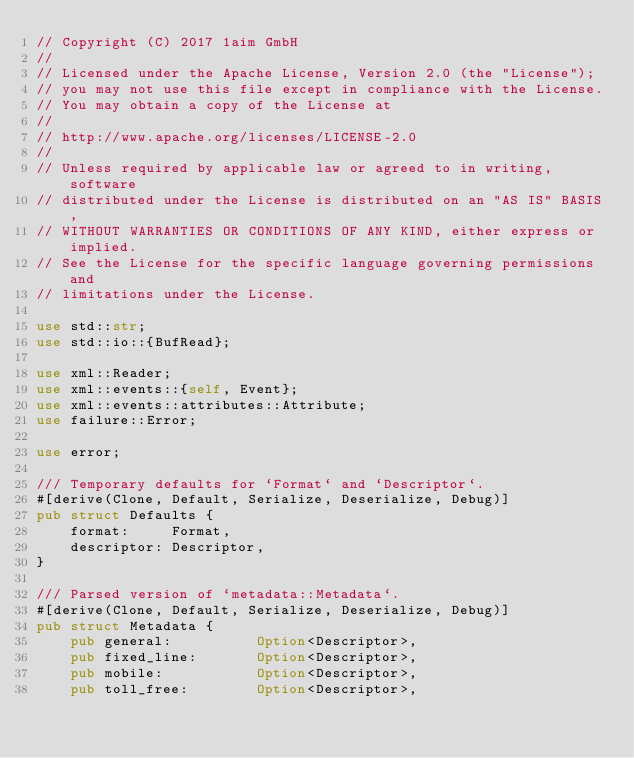Convert code to text. <code><loc_0><loc_0><loc_500><loc_500><_Rust_>// Copyright (C) 2017 1aim GmbH
//
// Licensed under the Apache License, Version 2.0 (the "License");
// you may not use this file except in compliance with the License.
// You may obtain a copy of the License at
//
// http://www.apache.org/licenses/LICENSE-2.0
//
// Unless required by applicable law or agreed to in writing, software
// distributed under the License is distributed on an "AS IS" BASIS,
// WITHOUT WARRANTIES OR CONDITIONS OF ANY KIND, either express or implied.
// See the License for the specific language governing permissions and
// limitations under the License.

use std::str;
use std::io::{BufRead};

use xml::Reader;
use xml::events::{self, Event};
use xml::events::attributes::Attribute;
use failure::Error;

use error;

/// Temporary defaults for `Format` and `Descriptor`.
#[derive(Clone, Default, Serialize, Deserialize, Debug)]
pub struct Defaults {
	format:     Format,
	descriptor: Descriptor,
}

/// Parsed version of `metadata::Metadata`.
#[derive(Clone, Default, Serialize, Deserialize, Debug)]
pub struct Metadata {
	pub general:          Option<Descriptor>,
	pub fixed_line:       Option<Descriptor>,
	pub mobile:           Option<Descriptor>,
	pub toll_free:        Option<Descriptor>,</code> 